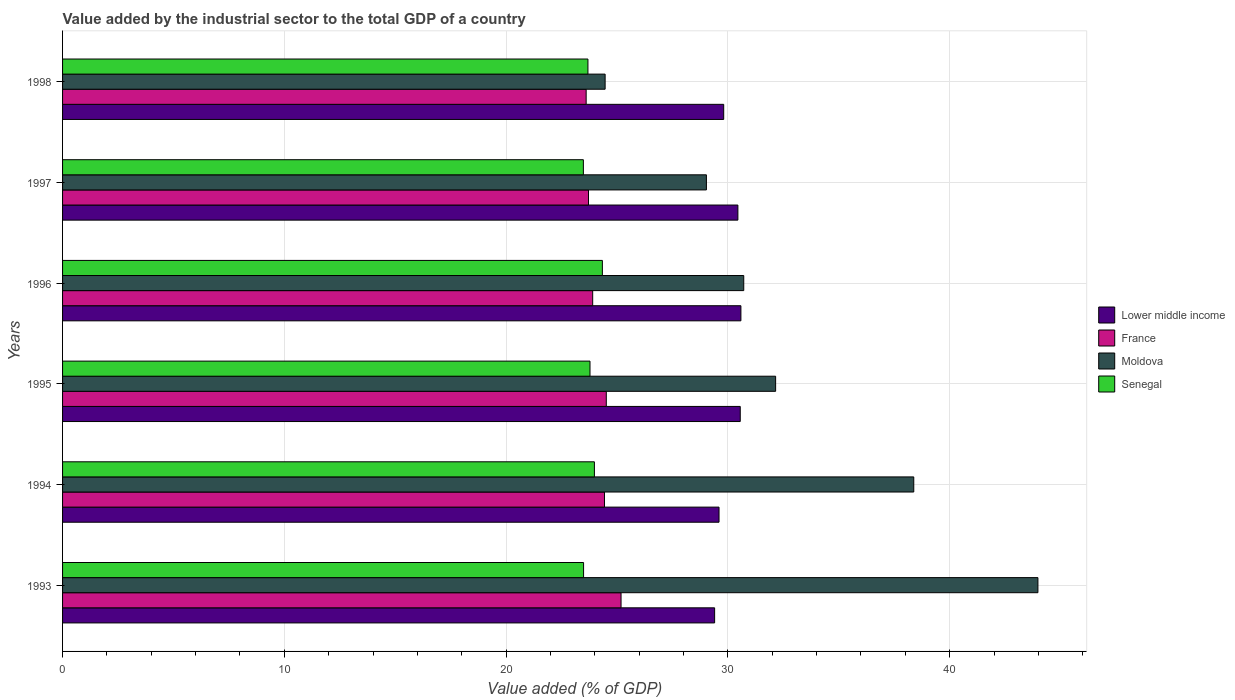Are the number of bars per tick equal to the number of legend labels?
Your response must be concise. Yes. What is the label of the 3rd group of bars from the top?
Your response must be concise. 1996. What is the value added by the industrial sector to the total GDP in Lower middle income in 1996?
Keep it short and to the point. 30.59. Across all years, what is the maximum value added by the industrial sector to the total GDP in France?
Your answer should be compact. 25.18. Across all years, what is the minimum value added by the industrial sector to the total GDP in Senegal?
Your answer should be very brief. 23.48. What is the total value added by the industrial sector to the total GDP in Senegal in the graph?
Your answer should be compact. 142.76. What is the difference between the value added by the industrial sector to the total GDP in France in 1993 and that in 1994?
Provide a short and direct response. 0.75. What is the difference between the value added by the industrial sector to the total GDP in France in 1996 and the value added by the industrial sector to the total GDP in Senegal in 1997?
Your answer should be very brief. 0.42. What is the average value added by the industrial sector to the total GDP in Moldova per year?
Keep it short and to the point. 33.12. In the year 1993, what is the difference between the value added by the industrial sector to the total GDP in Senegal and value added by the industrial sector to the total GDP in France?
Your answer should be very brief. -1.69. In how many years, is the value added by the industrial sector to the total GDP in Senegal greater than 40 %?
Provide a succinct answer. 0. What is the ratio of the value added by the industrial sector to the total GDP in Lower middle income in 1993 to that in 1996?
Keep it short and to the point. 0.96. Is the value added by the industrial sector to the total GDP in Senegal in 1995 less than that in 1996?
Provide a short and direct response. Yes. Is the difference between the value added by the industrial sector to the total GDP in Senegal in 1994 and 1996 greater than the difference between the value added by the industrial sector to the total GDP in France in 1994 and 1996?
Offer a terse response. No. What is the difference between the highest and the second highest value added by the industrial sector to the total GDP in France?
Keep it short and to the point. 0.66. What is the difference between the highest and the lowest value added by the industrial sector to the total GDP in Lower middle income?
Provide a succinct answer. 1.18. Is it the case that in every year, the sum of the value added by the industrial sector to the total GDP in Lower middle income and value added by the industrial sector to the total GDP in Senegal is greater than the sum of value added by the industrial sector to the total GDP in Moldova and value added by the industrial sector to the total GDP in France?
Provide a succinct answer. Yes. What does the 1st bar from the top in 1995 represents?
Ensure brevity in your answer.  Senegal. What does the 1st bar from the bottom in 1993 represents?
Your response must be concise. Lower middle income. Is it the case that in every year, the sum of the value added by the industrial sector to the total GDP in Moldova and value added by the industrial sector to the total GDP in Senegal is greater than the value added by the industrial sector to the total GDP in Lower middle income?
Offer a very short reply. Yes. How many bars are there?
Ensure brevity in your answer.  24. Are all the bars in the graph horizontal?
Offer a terse response. Yes. Are the values on the major ticks of X-axis written in scientific E-notation?
Provide a short and direct response. No. Does the graph contain any zero values?
Your answer should be very brief. No. Does the graph contain grids?
Provide a short and direct response. Yes. Where does the legend appear in the graph?
Provide a succinct answer. Center right. How many legend labels are there?
Provide a succinct answer. 4. How are the legend labels stacked?
Provide a short and direct response. Vertical. What is the title of the graph?
Keep it short and to the point. Value added by the industrial sector to the total GDP of a country. Does "Pacific island small states" appear as one of the legend labels in the graph?
Your response must be concise. No. What is the label or title of the X-axis?
Ensure brevity in your answer.  Value added (% of GDP). What is the label or title of the Y-axis?
Make the answer very short. Years. What is the Value added (% of GDP) in Lower middle income in 1993?
Offer a terse response. 29.4. What is the Value added (% of GDP) in France in 1993?
Provide a succinct answer. 25.18. What is the Value added (% of GDP) of Moldova in 1993?
Provide a short and direct response. 43.98. What is the Value added (% of GDP) of Senegal in 1993?
Offer a very short reply. 23.49. What is the Value added (% of GDP) of Lower middle income in 1994?
Keep it short and to the point. 29.6. What is the Value added (% of GDP) of France in 1994?
Ensure brevity in your answer.  24.43. What is the Value added (% of GDP) of Moldova in 1994?
Your answer should be very brief. 38.38. What is the Value added (% of GDP) of Senegal in 1994?
Make the answer very short. 23.98. What is the Value added (% of GDP) of Lower middle income in 1995?
Offer a very short reply. 30.56. What is the Value added (% of GDP) of France in 1995?
Your answer should be very brief. 24.52. What is the Value added (% of GDP) of Moldova in 1995?
Provide a succinct answer. 32.15. What is the Value added (% of GDP) in Senegal in 1995?
Your answer should be compact. 23.78. What is the Value added (% of GDP) of Lower middle income in 1996?
Your answer should be compact. 30.59. What is the Value added (% of GDP) of France in 1996?
Offer a very short reply. 23.9. What is the Value added (% of GDP) in Moldova in 1996?
Provide a succinct answer. 30.71. What is the Value added (% of GDP) in Senegal in 1996?
Your answer should be very brief. 24.34. What is the Value added (% of GDP) in Lower middle income in 1997?
Provide a succinct answer. 30.45. What is the Value added (% of GDP) of France in 1997?
Provide a short and direct response. 23.71. What is the Value added (% of GDP) in Moldova in 1997?
Provide a succinct answer. 29.03. What is the Value added (% of GDP) of Senegal in 1997?
Your answer should be compact. 23.48. What is the Value added (% of GDP) in Lower middle income in 1998?
Your response must be concise. 29.81. What is the Value added (% of GDP) of France in 1998?
Provide a succinct answer. 23.61. What is the Value added (% of GDP) of Moldova in 1998?
Give a very brief answer. 24.46. What is the Value added (% of GDP) of Senegal in 1998?
Provide a short and direct response. 23.69. Across all years, what is the maximum Value added (% of GDP) in Lower middle income?
Ensure brevity in your answer.  30.59. Across all years, what is the maximum Value added (% of GDP) in France?
Keep it short and to the point. 25.18. Across all years, what is the maximum Value added (% of GDP) of Moldova?
Keep it short and to the point. 43.98. Across all years, what is the maximum Value added (% of GDP) of Senegal?
Your response must be concise. 24.34. Across all years, what is the minimum Value added (% of GDP) in Lower middle income?
Your answer should be very brief. 29.4. Across all years, what is the minimum Value added (% of GDP) in France?
Ensure brevity in your answer.  23.61. Across all years, what is the minimum Value added (% of GDP) of Moldova?
Ensure brevity in your answer.  24.46. Across all years, what is the minimum Value added (% of GDP) of Senegal?
Keep it short and to the point. 23.48. What is the total Value added (% of GDP) of Lower middle income in the graph?
Your answer should be very brief. 180.4. What is the total Value added (% of GDP) in France in the graph?
Keep it short and to the point. 145.36. What is the total Value added (% of GDP) in Moldova in the graph?
Make the answer very short. 198.72. What is the total Value added (% of GDP) in Senegal in the graph?
Your answer should be very brief. 142.76. What is the difference between the Value added (% of GDP) in Lower middle income in 1993 and that in 1994?
Provide a succinct answer. -0.2. What is the difference between the Value added (% of GDP) of France in 1993 and that in 1994?
Your response must be concise. 0.75. What is the difference between the Value added (% of GDP) in Moldova in 1993 and that in 1994?
Your response must be concise. 5.6. What is the difference between the Value added (% of GDP) in Senegal in 1993 and that in 1994?
Offer a terse response. -0.49. What is the difference between the Value added (% of GDP) in Lower middle income in 1993 and that in 1995?
Make the answer very short. -1.16. What is the difference between the Value added (% of GDP) of France in 1993 and that in 1995?
Make the answer very short. 0.66. What is the difference between the Value added (% of GDP) in Moldova in 1993 and that in 1995?
Provide a succinct answer. 11.83. What is the difference between the Value added (% of GDP) of Senegal in 1993 and that in 1995?
Keep it short and to the point. -0.29. What is the difference between the Value added (% of GDP) of Lower middle income in 1993 and that in 1996?
Your response must be concise. -1.18. What is the difference between the Value added (% of GDP) of France in 1993 and that in 1996?
Offer a terse response. 1.28. What is the difference between the Value added (% of GDP) in Moldova in 1993 and that in 1996?
Provide a short and direct response. 13.26. What is the difference between the Value added (% of GDP) of Senegal in 1993 and that in 1996?
Make the answer very short. -0.85. What is the difference between the Value added (% of GDP) of Lower middle income in 1993 and that in 1997?
Offer a very short reply. -1.05. What is the difference between the Value added (% of GDP) in France in 1993 and that in 1997?
Ensure brevity in your answer.  1.47. What is the difference between the Value added (% of GDP) of Moldova in 1993 and that in 1997?
Provide a succinct answer. 14.95. What is the difference between the Value added (% of GDP) of Senegal in 1993 and that in 1997?
Offer a very short reply. 0.01. What is the difference between the Value added (% of GDP) of Lower middle income in 1993 and that in 1998?
Offer a very short reply. -0.41. What is the difference between the Value added (% of GDP) in France in 1993 and that in 1998?
Provide a succinct answer. 1.57. What is the difference between the Value added (% of GDP) of Moldova in 1993 and that in 1998?
Offer a very short reply. 19.51. What is the difference between the Value added (% of GDP) in Senegal in 1993 and that in 1998?
Your response must be concise. -0.2. What is the difference between the Value added (% of GDP) in Lower middle income in 1994 and that in 1995?
Your answer should be very brief. -0.96. What is the difference between the Value added (% of GDP) in France in 1994 and that in 1995?
Provide a short and direct response. -0.08. What is the difference between the Value added (% of GDP) of Moldova in 1994 and that in 1995?
Offer a very short reply. 6.23. What is the difference between the Value added (% of GDP) in Senegal in 1994 and that in 1995?
Make the answer very short. 0.2. What is the difference between the Value added (% of GDP) in Lower middle income in 1994 and that in 1996?
Your answer should be compact. -0.99. What is the difference between the Value added (% of GDP) in France in 1994 and that in 1996?
Your answer should be compact. 0.53. What is the difference between the Value added (% of GDP) in Moldova in 1994 and that in 1996?
Your answer should be compact. 7.67. What is the difference between the Value added (% of GDP) in Senegal in 1994 and that in 1996?
Your answer should be compact. -0.36. What is the difference between the Value added (% of GDP) in Lower middle income in 1994 and that in 1997?
Your answer should be very brief. -0.85. What is the difference between the Value added (% of GDP) in France in 1994 and that in 1997?
Ensure brevity in your answer.  0.72. What is the difference between the Value added (% of GDP) of Moldova in 1994 and that in 1997?
Offer a terse response. 9.35. What is the difference between the Value added (% of GDP) of Senegal in 1994 and that in 1997?
Offer a very short reply. 0.5. What is the difference between the Value added (% of GDP) in Lower middle income in 1994 and that in 1998?
Your answer should be very brief. -0.21. What is the difference between the Value added (% of GDP) of France in 1994 and that in 1998?
Ensure brevity in your answer.  0.83. What is the difference between the Value added (% of GDP) in Moldova in 1994 and that in 1998?
Offer a terse response. 13.92. What is the difference between the Value added (% of GDP) in Senegal in 1994 and that in 1998?
Provide a succinct answer. 0.29. What is the difference between the Value added (% of GDP) in Lower middle income in 1995 and that in 1996?
Give a very brief answer. -0.03. What is the difference between the Value added (% of GDP) of France in 1995 and that in 1996?
Keep it short and to the point. 0.61. What is the difference between the Value added (% of GDP) of Moldova in 1995 and that in 1996?
Your answer should be very brief. 1.44. What is the difference between the Value added (% of GDP) of Senegal in 1995 and that in 1996?
Ensure brevity in your answer.  -0.56. What is the difference between the Value added (% of GDP) of Lower middle income in 1995 and that in 1997?
Offer a very short reply. 0.11. What is the difference between the Value added (% of GDP) in France in 1995 and that in 1997?
Make the answer very short. 0.8. What is the difference between the Value added (% of GDP) in Moldova in 1995 and that in 1997?
Give a very brief answer. 3.12. What is the difference between the Value added (% of GDP) of Senegal in 1995 and that in 1997?
Give a very brief answer. 0.3. What is the difference between the Value added (% of GDP) of Lower middle income in 1995 and that in 1998?
Your answer should be very brief. 0.75. What is the difference between the Value added (% of GDP) in France in 1995 and that in 1998?
Your answer should be compact. 0.91. What is the difference between the Value added (% of GDP) of Moldova in 1995 and that in 1998?
Your answer should be very brief. 7.69. What is the difference between the Value added (% of GDP) of Senegal in 1995 and that in 1998?
Ensure brevity in your answer.  0.09. What is the difference between the Value added (% of GDP) of Lower middle income in 1996 and that in 1997?
Provide a succinct answer. 0.14. What is the difference between the Value added (% of GDP) in France in 1996 and that in 1997?
Your answer should be compact. 0.19. What is the difference between the Value added (% of GDP) in Moldova in 1996 and that in 1997?
Offer a very short reply. 1.68. What is the difference between the Value added (% of GDP) in Lower middle income in 1996 and that in 1998?
Make the answer very short. 0.78. What is the difference between the Value added (% of GDP) in France in 1996 and that in 1998?
Give a very brief answer. 0.29. What is the difference between the Value added (% of GDP) in Moldova in 1996 and that in 1998?
Your answer should be very brief. 6.25. What is the difference between the Value added (% of GDP) of Senegal in 1996 and that in 1998?
Your response must be concise. 0.65. What is the difference between the Value added (% of GDP) in Lower middle income in 1997 and that in 1998?
Offer a terse response. 0.64. What is the difference between the Value added (% of GDP) of France in 1997 and that in 1998?
Offer a terse response. 0.11. What is the difference between the Value added (% of GDP) in Moldova in 1997 and that in 1998?
Your response must be concise. 4.57. What is the difference between the Value added (% of GDP) in Senegal in 1997 and that in 1998?
Your response must be concise. -0.21. What is the difference between the Value added (% of GDP) of Lower middle income in 1993 and the Value added (% of GDP) of France in 1994?
Offer a very short reply. 4.97. What is the difference between the Value added (% of GDP) in Lower middle income in 1993 and the Value added (% of GDP) in Moldova in 1994?
Offer a terse response. -8.98. What is the difference between the Value added (% of GDP) of Lower middle income in 1993 and the Value added (% of GDP) of Senegal in 1994?
Provide a short and direct response. 5.42. What is the difference between the Value added (% of GDP) of France in 1993 and the Value added (% of GDP) of Moldova in 1994?
Your answer should be very brief. -13.2. What is the difference between the Value added (% of GDP) in France in 1993 and the Value added (% of GDP) in Senegal in 1994?
Make the answer very short. 1.2. What is the difference between the Value added (% of GDP) in Moldova in 1993 and the Value added (% of GDP) in Senegal in 1994?
Provide a short and direct response. 20. What is the difference between the Value added (% of GDP) in Lower middle income in 1993 and the Value added (% of GDP) in France in 1995?
Offer a terse response. 4.88. What is the difference between the Value added (% of GDP) in Lower middle income in 1993 and the Value added (% of GDP) in Moldova in 1995?
Provide a succinct answer. -2.75. What is the difference between the Value added (% of GDP) in Lower middle income in 1993 and the Value added (% of GDP) in Senegal in 1995?
Offer a very short reply. 5.62. What is the difference between the Value added (% of GDP) in France in 1993 and the Value added (% of GDP) in Moldova in 1995?
Keep it short and to the point. -6.97. What is the difference between the Value added (% of GDP) of France in 1993 and the Value added (% of GDP) of Senegal in 1995?
Make the answer very short. 1.4. What is the difference between the Value added (% of GDP) in Moldova in 1993 and the Value added (% of GDP) in Senegal in 1995?
Keep it short and to the point. 20.2. What is the difference between the Value added (% of GDP) of Lower middle income in 1993 and the Value added (% of GDP) of France in 1996?
Provide a short and direct response. 5.5. What is the difference between the Value added (% of GDP) of Lower middle income in 1993 and the Value added (% of GDP) of Moldova in 1996?
Give a very brief answer. -1.31. What is the difference between the Value added (% of GDP) of Lower middle income in 1993 and the Value added (% of GDP) of Senegal in 1996?
Your response must be concise. 5.06. What is the difference between the Value added (% of GDP) of France in 1993 and the Value added (% of GDP) of Moldova in 1996?
Your response must be concise. -5.53. What is the difference between the Value added (% of GDP) of France in 1993 and the Value added (% of GDP) of Senegal in 1996?
Make the answer very short. 0.84. What is the difference between the Value added (% of GDP) in Moldova in 1993 and the Value added (% of GDP) in Senegal in 1996?
Make the answer very short. 19.64. What is the difference between the Value added (% of GDP) in Lower middle income in 1993 and the Value added (% of GDP) in France in 1997?
Your answer should be very brief. 5.69. What is the difference between the Value added (% of GDP) in Lower middle income in 1993 and the Value added (% of GDP) in Moldova in 1997?
Your response must be concise. 0.37. What is the difference between the Value added (% of GDP) of Lower middle income in 1993 and the Value added (% of GDP) of Senegal in 1997?
Your answer should be compact. 5.92. What is the difference between the Value added (% of GDP) of France in 1993 and the Value added (% of GDP) of Moldova in 1997?
Your answer should be very brief. -3.85. What is the difference between the Value added (% of GDP) in France in 1993 and the Value added (% of GDP) in Senegal in 1997?
Provide a short and direct response. 1.7. What is the difference between the Value added (% of GDP) of Moldova in 1993 and the Value added (% of GDP) of Senegal in 1997?
Offer a terse response. 20.5. What is the difference between the Value added (% of GDP) in Lower middle income in 1993 and the Value added (% of GDP) in France in 1998?
Your response must be concise. 5.79. What is the difference between the Value added (% of GDP) of Lower middle income in 1993 and the Value added (% of GDP) of Moldova in 1998?
Offer a terse response. 4.94. What is the difference between the Value added (% of GDP) of Lower middle income in 1993 and the Value added (% of GDP) of Senegal in 1998?
Your response must be concise. 5.71. What is the difference between the Value added (% of GDP) of France in 1993 and the Value added (% of GDP) of Moldova in 1998?
Offer a terse response. 0.72. What is the difference between the Value added (% of GDP) in France in 1993 and the Value added (% of GDP) in Senegal in 1998?
Offer a terse response. 1.49. What is the difference between the Value added (% of GDP) of Moldova in 1993 and the Value added (% of GDP) of Senegal in 1998?
Offer a terse response. 20.29. What is the difference between the Value added (% of GDP) of Lower middle income in 1994 and the Value added (% of GDP) of France in 1995?
Your answer should be very brief. 5.08. What is the difference between the Value added (% of GDP) of Lower middle income in 1994 and the Value added (% of GDP) of Moldova in 1995?
Your answer should be very brief. -2.55. What is the difference between the Value added (% of GDP) in Lower middle income in 1994 and the Value added (% of GDP) in Senegal in 1995?
Provide a short and direct response. 5.82. What is the difference between the Value added (% of GDP) in France in 1994 and the Value added (% of GDP) in Moldova in 1995?
Make the answer very short. -7.72. What is the difference between the Value added (% of GDP) of France in 1994 and the Value added (% of GDP) of Senegal in 1995?
Make the answer very short. 0.65. What is the difference between the Value added (% of GDP) of Moldova in 1994 and the Value added (% of GDP) of Senegal in 1995?
Provide a short and direct response. 14.6. What is the difference between the Value added (% of GDP) in Lower middle income in 1994 and the Value added (% of GDP) in France in 1996?
Ensure brevity in your answer.  5.7. What is the difference between the Value added (% of GDP) in Lower middle income in 1994 and the Value added (% of GDP) in Moldova in 1996?
Your response must be concise. -1.11. What is the difference between the Value added (% of GDP) in Lower middle income in 1994 and the Value added (% of GDP) in Senegal in 1996?
Keep it short and to the point. 5.26. What is the difference between the Value added (% of GDP) in France in 1994 and the Value added (% of GDP) in Moldova in 1996?
Provide a short and direct response. -6.28. What is the difference between the Value added (% of GDP) of France in 1994 and the Value added (% of GDP) of Senegal in 1996?
Provide a short and direct response. 0.09. What is the difference between the Value added (% of GDP) in Moldova in 1994 and the Value added (% of GDP) in Senegal in 1996?
Provide a short and direct response. 14.04. What is the difference between the Value added (% of GDP) of Lower middle income in 1994 and the Value added (% of GDP) of France in 1997?
Your answer should be compact. 5.89. What is the difference between the Value added (% of GDP) in Lower middle income in 1994 and the Value added (% of GDP) in Moldova in 1997?
Keep it short and to the point. 0.57. What is the difference between the Value added (% of GDP) in Lower middle income in 1994 and the Value added (% of GDP) in Senegal in 1997?
Offer a terse response. 6.12. What is the difference between the Value added (% of GDP) in France in 1994 and the Value added (% of GDP) in Moldova in 1997?
Your answer should be compact. -4.6. What is the difference between the Value added (% of GDP) in France in 1994 and the Value added (% of GDP) in Senegal in 1997?
Your response must be concise. 0.95. What is the difference between the Value added (% of GDP) in Moldova in 1994 and the Value added (% of GDP) in Senegal in 1997?
Your answer should be compact. 14.9. What is the difference between the Value added (% of GDP) of Lower middle income in 1994 and the Value added (% of GDP) of France in 1998?
Your response must be concise. 5.99. What is the difference between the Value added (% of GDP) in Lower middle income in 1994 and the Value added (% of GDP) in Moldova in 1998?
Provide a succinct answer. 5.14. What is the difference between the Value added (% of GDP) of Lower middle income in 1994 and the Value added (% of GDP) of Senegal in 1998?
Provide a succinct answer. 5.91. What is the difference between the Value added (% of GDP) of France in 1994 and the Value added (% of GDP) of Moldova in 1998?
Provide a succinct answer. -0.03. What is the difference between the Value added (% of GDP) of France in 1994 and the Value added (% of GDP) of Senegal in 1998?
Ensure brevity in your answer.  0.75. What is the difference between the Value added (% of GDP) in Moldova in 1994 and the Value added (% of GDP) in Senegal in 1998?
Keep it short and to the point. 14.69. What is the difference between the Value added (% of GDP) in Lower middle income in 1995 and the Value added (% of GDP) in France in 1996?
Your response must be concise. 6.65. What is the difference between the Value added (% of GDP) of Lower middle income in 1995 and the Value added (% of GDP) of Moldova in 1996?
Give a very brief answer. -0.16. What is the difference between the Value added (% of GDP) in Lower middle income in 1995 and the Value added (% of GDP) in Senegal in 1996?
Keep it short and to the point. 6.22. What is the difference between the Value added (% of GDP) in France in 1995 and the Value added (% of GDP) in Moldova in 1996?
Keep it short and to the point. -6.2. What is the difference between the Value added (% of GDP) of France in 1995 and the Value added (% of GDP) of Senegal in 1996?
Offer a very short reply. 0.18. What is the difference between the Value added (% of GDP) of Moldova in 1995 and the Value added (% of GDP) of Senegal in 1996?
Make the answer very short. 7.81. What is the difference between the Value added (% of GDP) of Lower middle income in 1995 and the Value added (% of GDP) of France in 1997?
Offer a very short reply. 6.84. What is the difference between the Value added (% of GDP) in Lower middle income in 1995 and the Value added (% of GDP) in Moldova in 1997?
Your answer should be compact. 1.53. What is the difference between the Value added (% of GDP) in Lower middle income in 1995 and the Value added (% of GDP) in Senegal in 1997?
Keep it short and to the point. 7.07. What is the difference between the Value added (% of GDP) in France in 1995 and the Value added (% of GDP) in Moldova in 1997?
Keep it short and to the point. -4.51. What is the difference between the Value added (% of GDP) of France in 1995 and the Value added (% of GDP) of Senegal in 1997?
Offer a very short reply. 1.03. What is the difference between the Value added (% of GDP) in Moldova in 1995 and the Value added (% of GDP) in Senegal in 1997?
Your answer should be very brief. 8.67. What is the difference between the Value added (% of GDP) in Lower middle income in 1995 and the Value added (% of GDP) in France in 1998?
Provide a succinct answer. 6.95. What is the difference between the Value added (% of GDP) in Lower middle income in 1995 and the Value added (% of GDP) in Moldova in 1998?
Your answer should be very brief. 6.09. What is the difference between the Value added (% of GDP) of Lower middle income in 1995 and the Value added (% of GDP) of Senegal in 1998?
Your answer should be compact. 6.87. What is the difference between the Value added (% of GDP) in France in 1995 and the Value added (% of GDP) in Moldova in 1998?
Offer a very short reply. 0.05. What is the difference between the Value added (% of GDP) of France in 1995 and the Value added (% of GDP) of Senegal in 1998?
Your answer should be compact. 0.83. What is the difference between the Value added (% of GDP) in Moldova in 1995 and the Value added (% of GDP) in Senegal in 1998?
Offer a very short reply. 8.46. What is the difference between the Value added (% of GDP) of Lower middle income in 1996 and the Value added (% of GDP) of France in 1997?
Ensure brevity in your answer.  6.87. What is the difference between the Value added (% of GDP) in Lower middle income in 1996 and the Value added (% of GDP) in Moldova in 1997?
Give a very brief answer. 1.56. What is the difference between the Value added (% of GDP) in Lower middle income in 1996 and the Value added (% of GDP) in Senegal in 1997?
Provide a succinct answer. 7.1. What is the difference between the Value added (% of GDP) in France in 1996 and the Value added (% of GDP) in Moldova in 1997?
Provide a short and direct response. -5.13. What is the difference between the Value added (% of GDP) of France in 1996 and the Value added (% of GDP) of Senegal in 1997?
Ensure brevity in your answer.  0.42. What is the difference between the Value added (% of GDP) in Moldova in 1996 and the Value added (% of GDP) in Senegal in 1997?
Keep it short and to the point. 7.23. What is the difference between the Value added (% of GDP) in Lower middle income in 1996 and the Value added (% of GDP) in France in 1998?
Provide a short and direct response. 6.98. What is the difference between the Value added (% of GDP) of Lower middle income in 1996 and the Value added (% of GDP) of Moldova in 1998?
Make the answer very short. 6.12. What is the difference between the Value added (% of GDP) of Lower middle income in 1996 and the Value added (% of GDP) of Senegal in 1998?
Keep it short and to the point. 6.9. What is the difference between the Value added (% of GDP) in France in 1996 and the Value added (% of GDP) in Moldova in 1998?
Offer a very short reply. -0.56. What is the difference between the Value added (% of GDP) in France in 1996 and the Value added (% of GDP) in Senegal in 1998?
Offer a very short reply. 0.21. What is the difference between the Value added (% of GDP) of Moldova in 1996 and the Value added (% of GDP) of Senegal in 1998?
Offer a very short reply. 7.03. What is the difference between the Value added (% of GDP) of Lower middle income in 1997 and the Value added (% of GDP) of France in 1998?
Make the answer very short. 6.84. What is the difference between the Value added (% of GDP) of Lower middle income in 1997 and the Value added (% of GDP) of Moldova in 1998?
Keep it short and to the point. 5.99. What is the difference between the Value added (% of GDP) of Lower middle income in 1997 and the Value added (% of GDP) of Senegal in 1998?
Make the answer very short. 6.76. What is the difference between the Value added (% of GDP) of France in 1997 and the Value added (% of GDP) of Moldova in 1998?
Keep it short and to the point. -0.75. What is the difference between the Value added (% of GDP) of France in 1997 and the Value added (% of GDP) of Senegal in 1998?
Offer a very short reply. 0.03. What is the difference between the Value added (% of GDP) of Moldova in 1997 and the Value added (% of GDP) of Senegal in 1998?
Give a very brief answer. 5.34. What is the average Value added (% of GDP) in Lower middle income per year?
Make the answer very short. 30.07. What is the average Value added (% of GDP) of France per year?
Ensure brevity in your answer.  24.23. What is the average Value added (% of GDP) of Moldova per year?
Your answer should be compact. 33.12. What is the average Value added (% of GDP) in Senegal per year?
Keep it short and to the point. 23.79. In the year 1993, what is the difference between the Value added (% of GDP) of Lower middle income and Value added (% of GDP) of France?
Offer a very short reply. 4.22. In the year 1993, what is the difference between the Value added (% of GDP) of Lower middle income and Value added (% of GDP) of Moldova?
Make the answer very short. -14.58. In the year 1993, what is the difference between the Value added (% of GDP) in Lower middle income and Value added (% of GDP) in Senegal?
Provide a succinct answer. 5.91. In the year 1993, what is the difference between the Value added (% of GDP) of France and Value added (% of GDP) of Moldova?
Offer a terse response. -18.8. In the year 1993, what is the difference between the Value added (% of GDP) of France and Value added (% of GDP) of Senegal?
Offer a terse response. 1.69. In the year 1993, what is the difference between the Value added (% of GDP) of Moldova and Value added (% of GDP) of Senegal?
Your answer should be compact. 20.49. In the year 1994, what is the difference between the Value added (% of GDP) of Lower middle income and Value added (% of GDP) of France?
Keep it short and to the point. 5.17. In the year 1994, what is the difference between the Value added (% of GDP) in Lower middle income and Value added (% of GDP) in Moldova?
Your response must be concise. -8.78. In the year 1994, what is the difference between the Value added (% of GDP) of Lower middle income and Value added (% of GDP) of Senegal?
Provide a succinct answer. 5.62. In the year 1994, what is the difference between the Value added (% of GDP) of France and Value added (% of GDP) of Moldova?
Give a very brief answer. -13.95. In the year 1994, what is the difference between the Value added (% of GDP) of France and Value added (% of GDP) of Senegal?
Ensure brevity in your answer.  0.45. In the year 1994, what is the difference between the Value added (% of GDP) in Moldova and Value added (% of GDP) in Senegal?
Your answer should be very brief. 14.4. In the year 1995, what is the difference between the Value added (% of GDP) of Lower middle income and Value added (% of GDP) of France?
Your response must be concise. 6.04. In the year 1995, what is the difference between the Value added (% of GDP) of Lower middle income and Value added (% of GDP) of Moldova?
Your response must be concise. -1.6. In the year 1995, what is the difference between the Value added (% of GDP) of Lower middle income and Value added (% of GDP) of Senegal?
Your answer should be compact. 6.77. In the year 1995, what is the difference between the Value added (% of GDP) of France and Value added (% of GDP) of Moldova?
Make the answer very short. -7.63. In the year 1995, what is the difference between the Value added (% of GDP) in France and Value added (% of GDP) in Senegal?
Offer a very short reply. 0.73. In the year 1995, what is the difference between the Value added (% of GDP) in Moldova and Value added (% of GDP) in Senegal?
Your answer should be compact. 8.37. In the year 1996, what is the difference between the Value added (% of GDP) of Lower middle income and Value added (% of GDP) of France?
Provide a succinct answer. 6.68. In the year 1996, what is the difference between the Value added (% of GDP) in Lower middle income and Value added (% of GDP) in Moldova?
Provide a succinct answer. -0.13. In the year 1996, what is the difference between the Value added (% of GDP) in Lower middle income and Value added (% of GDP) in Senegal?
Give a very brief answer. 6.25. In the year 1996, what is the difference between the Value added (% of GDP) of France and Value added (% of GDP) of Moldova?
Your answer should be very brief. -6.81. In the year 1996, what is the difference between the Value added (% of GDP) in France and Value added (% of GDP) in Senegal?
Keep it short and to the point. -0.44. In the year 1996, what is the difference between the Value added (% of GDP) of Moldova and Value added (% of GDP) of Senegal?
Offer a terse response. 6.37. In the year 1997, what is the difference between the Value added (% of GDP) in Lower middle income and Value added (% of GDP) in France?
Offer a terse response. 6.74. In the year 1997, what is the difference between the Value added (% of GDP) of Lower middle income and Value added (% of GDP) of Moldova?
Provide a succinct answer. 1.42. In the year 1997, what is the difference between the Value added (% of GDP) of Lower middle income and Value added (% of GDP) of Senegal?
Your response must be concise. 6.97. In the year 1997, what is the difference between the Value added (% of GDP) of France and Value added (% of GDP) of Moldova?
Your response must be concise. -5.32. In the year 1997, what is the difference between the Value added (% of GDP) of France and Value added (% of GDP) of Senegal?
Offer a very short reply. 0.23. In the year 1997, what is the difference between the Value added (% of GDP) of Moldova and Value added (% of GDP) of Senegal?
Your answer should be compact. 5.55. In the year 1998, what is the difference between the Value added (% of GDP) in Lower middle income and Value added (% of GDP) in France?
Ensure brevity in your answer.  6.2. In the year 1998, what is the difference between the Value added (% of GDP) of Lower middle income and Value added (% of GDP) of Moldova?
Your answer should be compact. 5.35. In the year 1998, what is the difference between the Value added (% of GDP) in Lower middle income and Value added (% of GDP) in Senegal?
Make the answer very short. 6.12. In the year 1998, what is the difference between the Value added (% of GDP) in France and Value added (% of GDP) in Moldova?
Offer a very short reply. -0.86. In the year 1998, what is the difference between the Value added (% of GDP) of France and Value added (% of GDP) of Senegal?
Your response must be concise. -0.08. In the year 1998, what is the difference between the Value added (% of GDP) in Moldova and Value added (% of GDP) in Senegal?
Your answer should be compact. 0.78. What is the ratio of the Value added (% of GDP) of France in 1993 to that in 1994?
Your answer should be very brief. 1.03. What is the ratio of the Value added (% of GDP) in Moldova in 1993 to that in 1994?
Provide a short and direct response. 1.15. What is the ratio of the Value added (% of GDP) of Senegal in 1993 to that in 1994?
Your answer should be very brief. 0.98. What is the ratio of the Value added (% of GDP) of Lower middle income in 1993 to that in 1995?
Your answer should be very brief. 0.96. What is the ratio of the Value added (% of GDP) in France in 1993 to that in 1995?
Give a very brief answer. 1.03. What is the ratio of the Value added (% of GDP) in Moldova in 1993 to that in 1995?
Your answer should be compact. 1.37. What is the ratio of the Value added (% of GDP) of Senegal in 1993 to that in 1995?
Provide a succinct answer. 0.99. What is the ratio of the Value added (% of GDP) of Lower middle income in 1993 to that in 1996?
Provide a short and direct response. 0.96. What is the ratio of the Value added (% of GDP) of France in 1993 to that in 1996?
Give a very brief answer. 1.05. What is the ratio of the Value added (% of GDP) of Moldova in 1993 to that in 1996?
Offer a very short reply. 1.43. What is the ratio of the Value added (% of GDP) in Senegal in 1993 to that in 1996?
Provide a short and direct response. 0.97. What is the ratio of the Value added (% of GDP) of Lower middle income in 1993 to that in 1997?
Your answer should be very brief. 0.97. What is the ratio of the Value added (% of GDP) of France in 1993 to that in 1997?
Offer a terse response. 1.06. What is the ratio of the Value added (% of GDP) in Moldova in 1993 to that in 1997?
Your answer should be very brief. 1.51. What is the ratio of the Value added (% of GDP) of Senegal in 1993 to that in 1997?
Provide a succinct answer. 1. What is the ratio of the Value added (% of GDP) of Lower middle income in 1993 to that in 1998?
Give a very brief answer. 0.99. What is the ratio of the Value added (% of GDP) in France in 1993 to that in 1998?
Ensure brevity in your answer.  1.07. What is the ratio of the Value added (% of GDP) of Moldova in 1993 to that in 1998?
Offer a terse response. 1.8. What is the ratio of the Value added (% of GDP) of Senegal in 1993 to that in 1998?
Provide a short and direct response. 0.99. What is the ratio of the Value added (% of GDP) in Lower middle income in 1994 to that in 1995?
Provide a succinct answer. 0.97. What is the ratio of the Value added (% of GDP) in Moldova in 1994 to that in 1995?
Your answer should be very brief. 1.19. What is the ratio of the Value added (% of GDP) of Senegal in 1994 to that in 1995?
Provide a succinct answer. 1.01. What is the ratio of the Value added (% of GDP) of Lower middle income in 1994 to that in 1996?
Make the answer very short. 0.97. What is the ratio of the Value added (% of GDP) of France in 1994 to that in 1996?
Give a very brief answer. 1.02. What is the ratio of the Value added (% of GDP) in Moldova in 1994 to that in 1996?
Ensure brevity in your answer.  1.25. What is the ratio of the Value added (% of GDP) of Senegal in 1994 to that in 1996?
Offer a very short reply. 0.99. What is the ratio of the Value added (% of GDP) of Lower middle income in 1994 to that in 1997?
Provide a short and direct response. 0.97. What is the ratio of the Value added (% of GDP) of France in 1994 to that in 1997?
Offer a terse response. 1.03. What is the ratio of the Value added (% of GDP) of Moldova in 1994 to that in 1997?
Offer a terse response. 1.32. What is the ratio of the Value added (% of GDP) of Senegal in 1994 to that in 1997?
Keep it short and to the point. 1.02. What is the ratio of the Value added (% of GDP) of France in 1994 to that in 1998?
Your answer should be compact. 1.03. What is the ratio of the Value added (% of GDP) of Moldova in 1994 to that in 1998?
Keep it short and to the point. 1.57. What is the ratio of the Value added (% of GDP) of Senegal in 1994 to that in 1998?
Give a very brief answer. 1.01. What is the ratio of the Value added (% of GDP) in Lower middle income in 1995 to that in 1996?
Make the answer very short. 1. What is the ratio of the Value added (% of GDP) in France in 1995 to that in 1996?
Your answer should be compact. 1.03. What is the ratio of the Value added (% of GDP) of Moldova in 1995 to that in 1996?
Ensure brevity in your answer.  1.05. What is the ratio of the Value added (% of GDP) of Senegal in 1995 to that in 1996?
Offer a very short reply. 0.98. What is the ratio of the Value added (% of GDP) in France in 1995 to that in 1997?
Make the answer very short. 1.03. What is the ratio of the Value added (% of GDP) in Moldova in 1995 to that in 1997?
Your answer should be very brief. 1.11. What is the ratio of the Value added (% of GDP) of Senegal in 1995 to that in 1997?
Your answer should be compact. 1.01. What is the ratio of the Value added (% of GDP) in Moldova in 1995 to that in 1998?
Your response must be concise. 1.31. What is the ratio of the Value added (% of GDP) in Senegal in 1995 to that in 1998?
Provide a short and direct response. 1. What is the ratio of the Value added (% of GDP) in Moldova in 1996 to that in 1997?
Provide a short and direct response. 1.06. What is the ratio of the Value added (% of GDP) of Senegal in 1996 to that in 1997?
Ensure brevity in your answer.  1.04. What is the ratio of the Value added (% of GDP) of Lower middle income in 1996 to that in 1998?
Provide a short and direct response. 1.03. What is the ratio of the Value added (% of GDP) of France in 1996 to that in 1998?
Ensure brevity in your answer.  1.01. What is the ratio of the Value added (% of GDP) of Moldova in 1996 to that in 1998?
Ensure brevity in your answer.  1.26. What is the ratio of the Value added (% of GDP) in Senegal in 1996 to that in 1998?
Make the answer very short. 1.03. What is the ratio of the Value added (% of GDP) of Lower middle income in 1997 to that in 1998?
Offer a terse response. 1.02. What is the ratio of the Value added (% of GDP) of France in 1997 to that in 1998?
Your response must be concise. 1. What is the ratio of the Value added (% of GDP) in Moldova in 1997 to that in 1998?
Your answer should be compact. 1.19. What is the ratio of the Value added (% of GDP) in Senegal in 1997 to that in 1998?
Give a very brief answer. 0.99. What is the difference between the highest and the second highest Value added (% of GDP) in Lower middle income?
Provide a succinct answer. 0.03. What is the difference between the highest and the second highest Value added (% of GDP) of France?
Your answer should be compact. 0.66. What is the difference between the highest and the second highest Value added (% of GDP) of Moldova?
Keep it short and to the point. 5.6. What is the difference between the highest and the second highest Value added (% of GDP) in Senegal?
Offer a very short reply. 0.36. What is the difference between the highest and the lowest Value added (% of GDP) in Lower middle income?
Keep it short and to the point. 1.18. What is the difference between the highest and the lowest Value added (% of GDP) of France?
Your answer should be very brief. 1.57. What is the difference between the highest and the lowest Value added (% of GDP) in Moldova?
Make the answer very short. 19.51. 